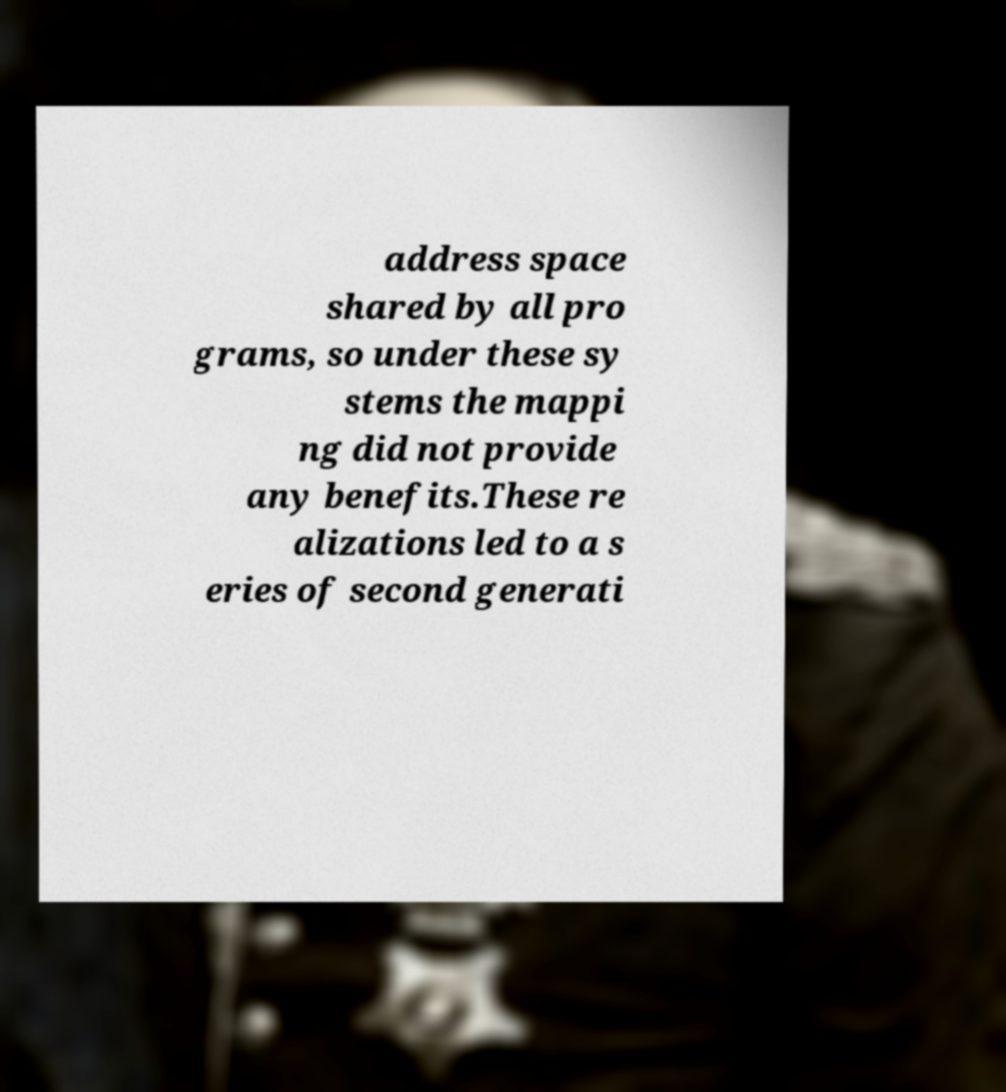Could you extract and type out the text from this image? address space shared by all pro grams, so under these sy stems the mappi ng did not provide any benefits.These re alizations led to a s eries of second generati 